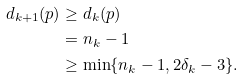<formula> <loc_0><loc_0><loc_500><loc_500>d _ { k + 1 } ( p ) & \geq d _ { k } ( p ) \\ & = n _ { k } - 1 \\ & \geq \min \{ n _ { k } - 1 , 2 \delta _ { k } - 3 \} .</formula> 